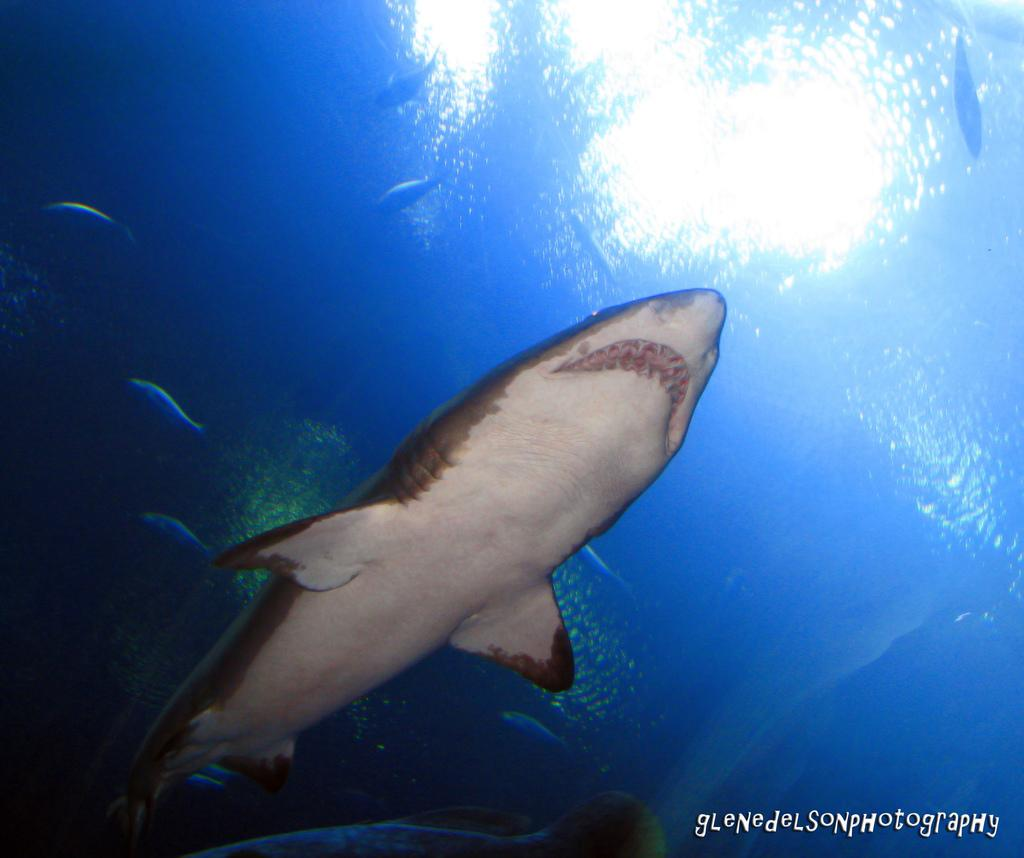What type of animals can be seen in the image? There are fishes and a shark in the image. What are the fishes and shark doing in the image? The fishes and shark are moving in the water. What color is the water in the image? The water is blue in color. Is there any additional information or branding on the image? Yes, there is a watermark on the image. How many brothers are shown playing with the faucet in the image? There are no brothers or faucets present in the image; it features fishes and a shark in blue water. 